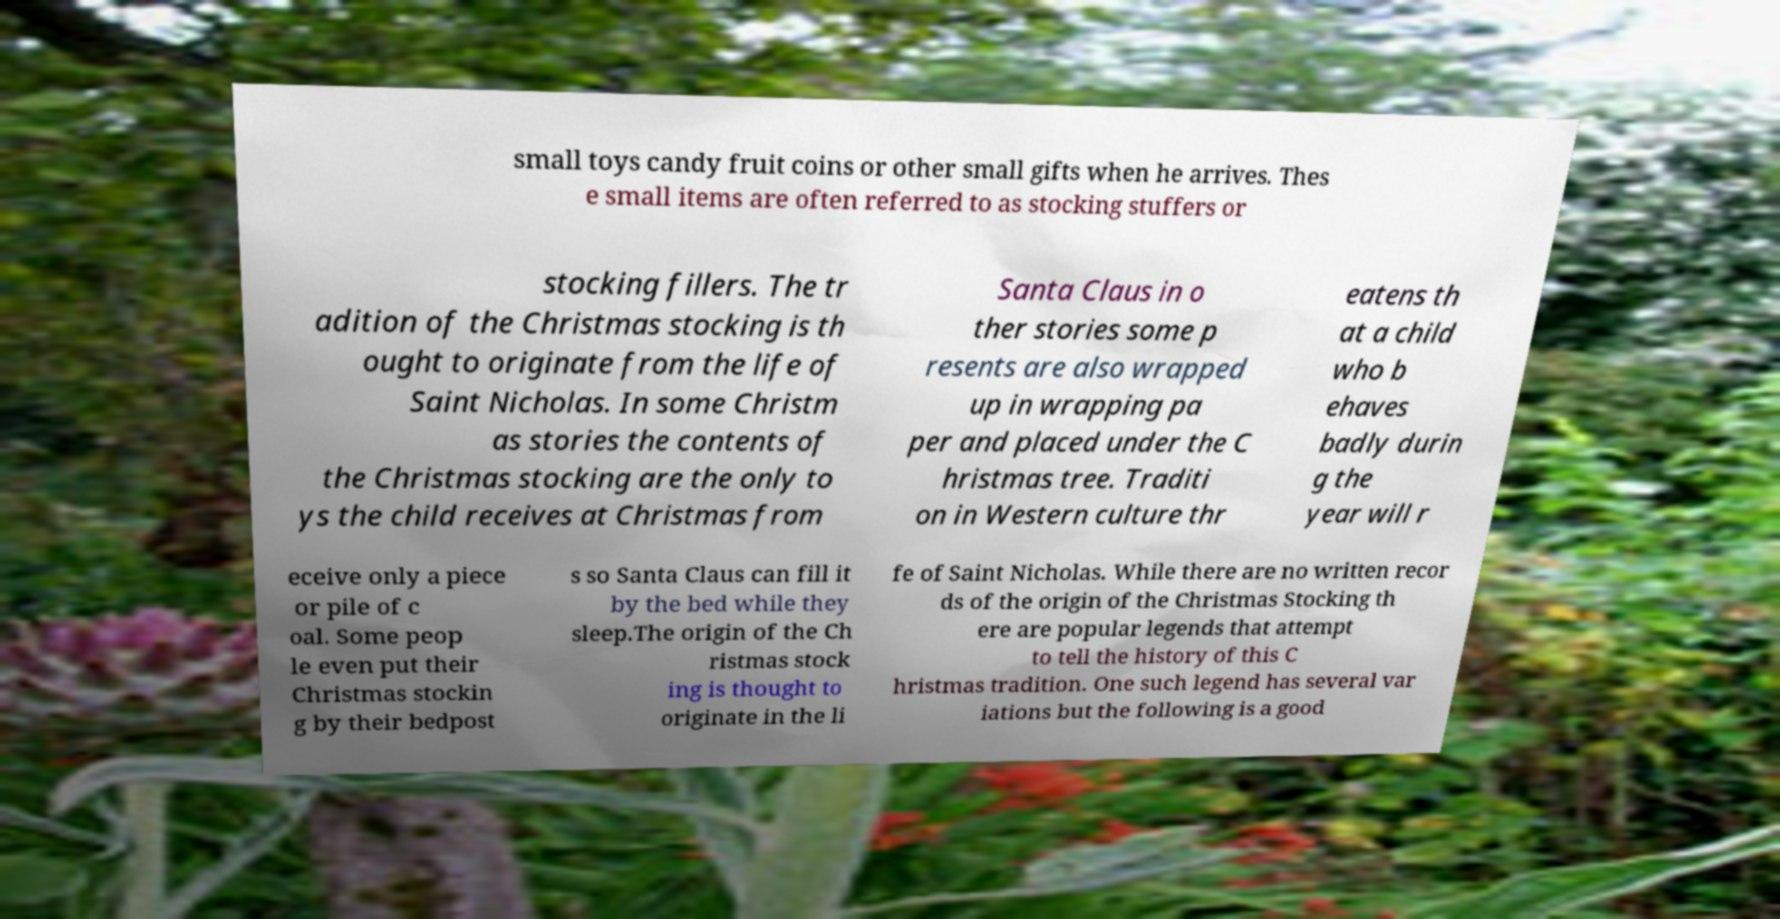There's text embedded in this image that I need extracted. Can you transcribe it verbatim? small toys candy fruit coins or other small gifts when he arrives. Thes e small items are often referred to as stocking stuffers or stocking fillers. The tr adition of the Christmas stocking is th ought to originate from the life of Saint Nicholas. In some Christm as stories the contents of the Christmas stocking are the only to ys the child receives at Christmas from Santa Claus in o ther stories some p resents are also wrapped up in wrapping pa per and placed under the C hristmas tree. Traditi on in Western culture thr eatens th at a child who b ehaves badly durin g the year will r eceive only a piece or pile of c oal. Some peop le even put their Christmas stockin g by their bedpost s so Santa Claus can fill it by the bed while they sleep.The origin of the Ch ristmas stock ing is thought to originate in the li fe of Saint Nicholas. While there are no written recor ds of the origin of the Christmas Stocking th ere are popular legends that attempt to tell the history of this C hristmas tradition. One such legend has several var iations but the following is a good 